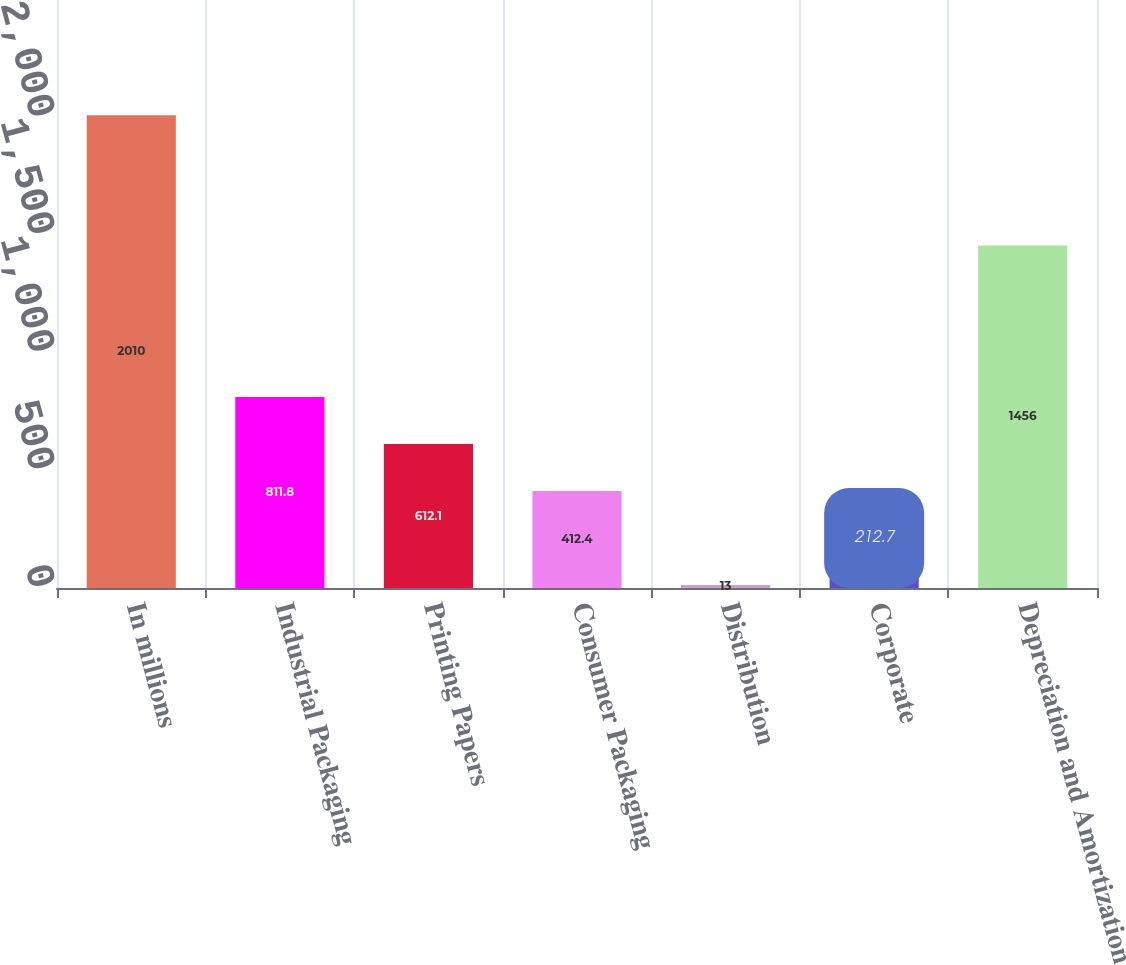Convert chart to OTSL. <chart><loc_0><loc_0><loc_500><loc_500><bar_chart><fcel>In millions<fcel>Industrial Packaging<fcel>Printing Papers<fcel>Consumer Packaging<fcel>Distribution<fcel>Corporate<fcel>Depreciation and Amortization<nl><fcel>2010<fcel>811.8<fcel>612.1<fcel>412.4<fcel>13<fcel>212.7<fcel>1456<nl></chart> 